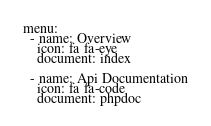<code> <loc_0><loc_0><loc_500><loc_500><_YAML_>menu:
  - name: Overview
    icon: fa fa-eye
    document: index

  - name: Api Documentation
    icon: fa fa-code
    document: phpdoc</code> 